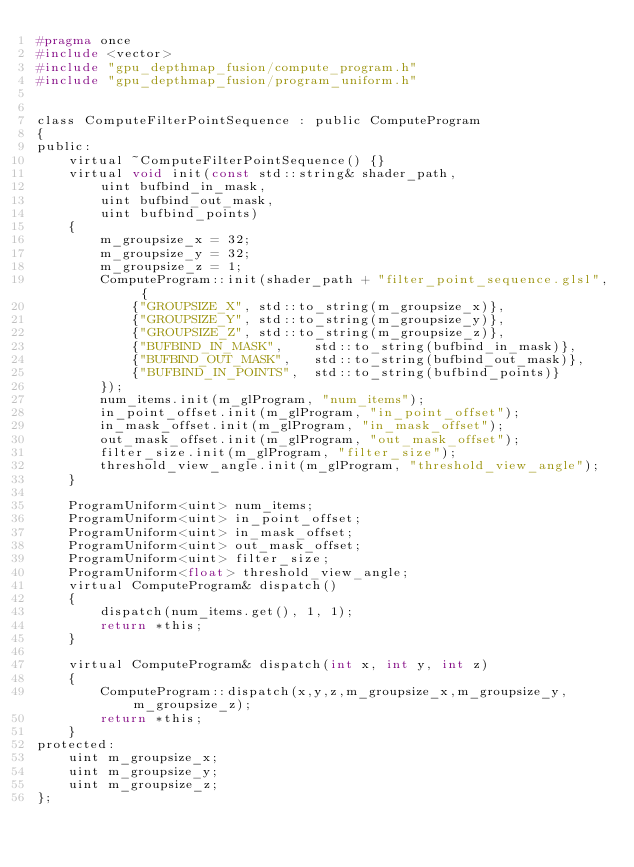<code> <loc_0><loc_0><loc_500><loc_500><_C_>#pragma once
#include <vector>
#include "gpu_depthmap_fusion/compute_program.h"
#include "gpu_depthmap_fusion/program_uniform.h"


class ComputeFilterPointSequence : public ComputeProgram
{
public:
    virtual ~ComputeFilterPointSequence() {}
    virtual void init(const std::string& shader_path, 
        uint bufbind_in_mask, 
        uint bufbind_out_mask, 
        uint bufbind_points)
    {
        m_groupsize_x = 32;
        m_groupsize_y = 32;
        m_groupsize_z = 1;        
        ComputeProgram::init(shader_path + "filter_point_sequence.glsl", {
            {"GROUPSIZE_X", std::to_string(m_groupsize_x)},
            {"GROUPSIZE_Y", std::to_string(m_groupsize_y)},
            {"GROUPSIZE_Z", std::to_string(m_groupsize_z)},
            {"BUFBIND_IN_MASK",    std::to_string(bufbind_in_mask)},
            {"BUFBIND_OUT_MASK",   std::to_string(bufbind_out_mask)},
            {"BUFBIND_IN_POINTS",  std::to_string(bufbind_points)}
        });
        num_items.init(m_glProgram, "num_items");
        in_point_offset.init(m_glProgram, "in_point_offset");
        in_mask_offset.init(m_glProgram, "in_mask_offset");
        out_mask_offset.init(m_glProgram, "out_mask_offset");
        filter_size.init(m_glProgram, "filter_size");
        threshold_view_angle.init(m_glProgram, "threshold_view_angle");
    }

    ProgramUniform<uint> num_items;
    ProgramUniform<uint> in_point_offset;
    ProgramUniform<uint> in_mask_offset;
    ProgramUniform<uint> out_mask_offset;
    ProgramUniform<uint> filter_size;
    ProgramUniform<float> threshold_view_angle;
    virtual ComputeProgram& dispatch()
    {
        dispatch(num_items.get(), 1, 1);
        return *this;
    }

    virtual ComputeProgram& dispatch(int x, int y, int z)
    {
        ComputeProgram::dispatch(x,y,z,m_groupsize_x,m_groupsize_y,m_groupsize_z);
        return *this;
    }
protected:
    uint m_groupsize_x;
    uint m_groupsize_y;
    uint m_groupsize_z;
};

</code> 